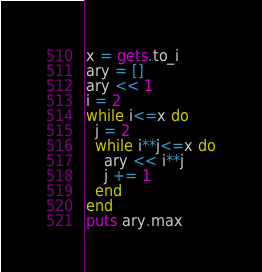<code> <loc_0><loc_0><loc_500><loc_500><_Ruby_>x = gets.to_i
ary = []
ary << 1
i = 2
while i<=x do
  j = 2
  while i**j<=x do
    ary << i**j
    j += 1
  end
end
puts ary.max</code> 